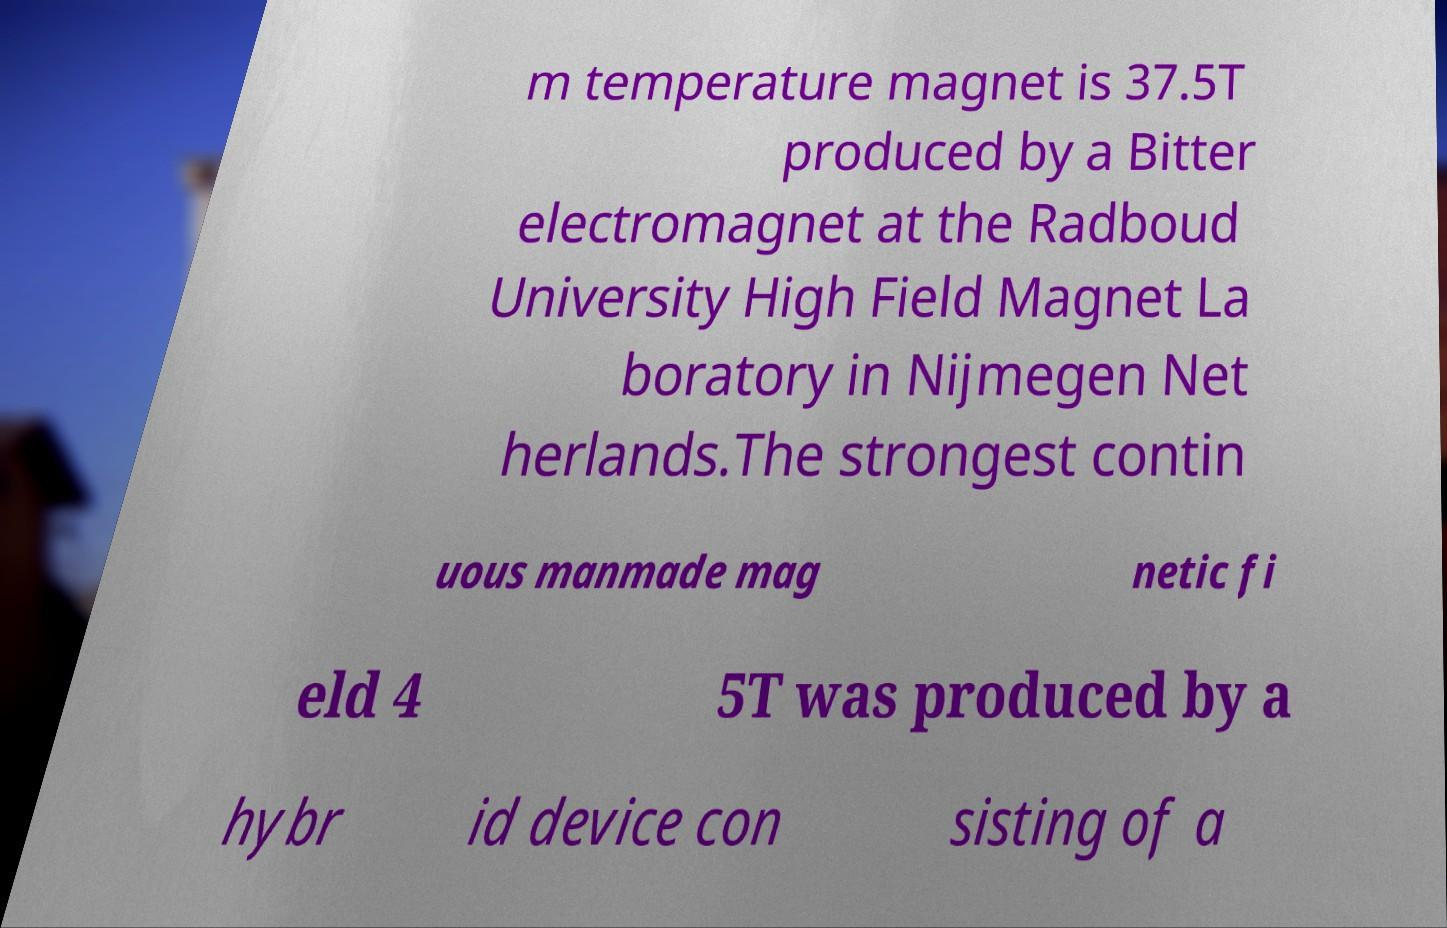I need the written content from this picture converted into text. Can you do that? m temperature magnet is 37.5T produced by a Bitter electromagnet at the Radboud University High Field Magnet La boratory in Nijmegen Net herlands.The strongest contin uous manmade mag netic fi eld 4 5T was produced by a hybr id device con sisting of a 